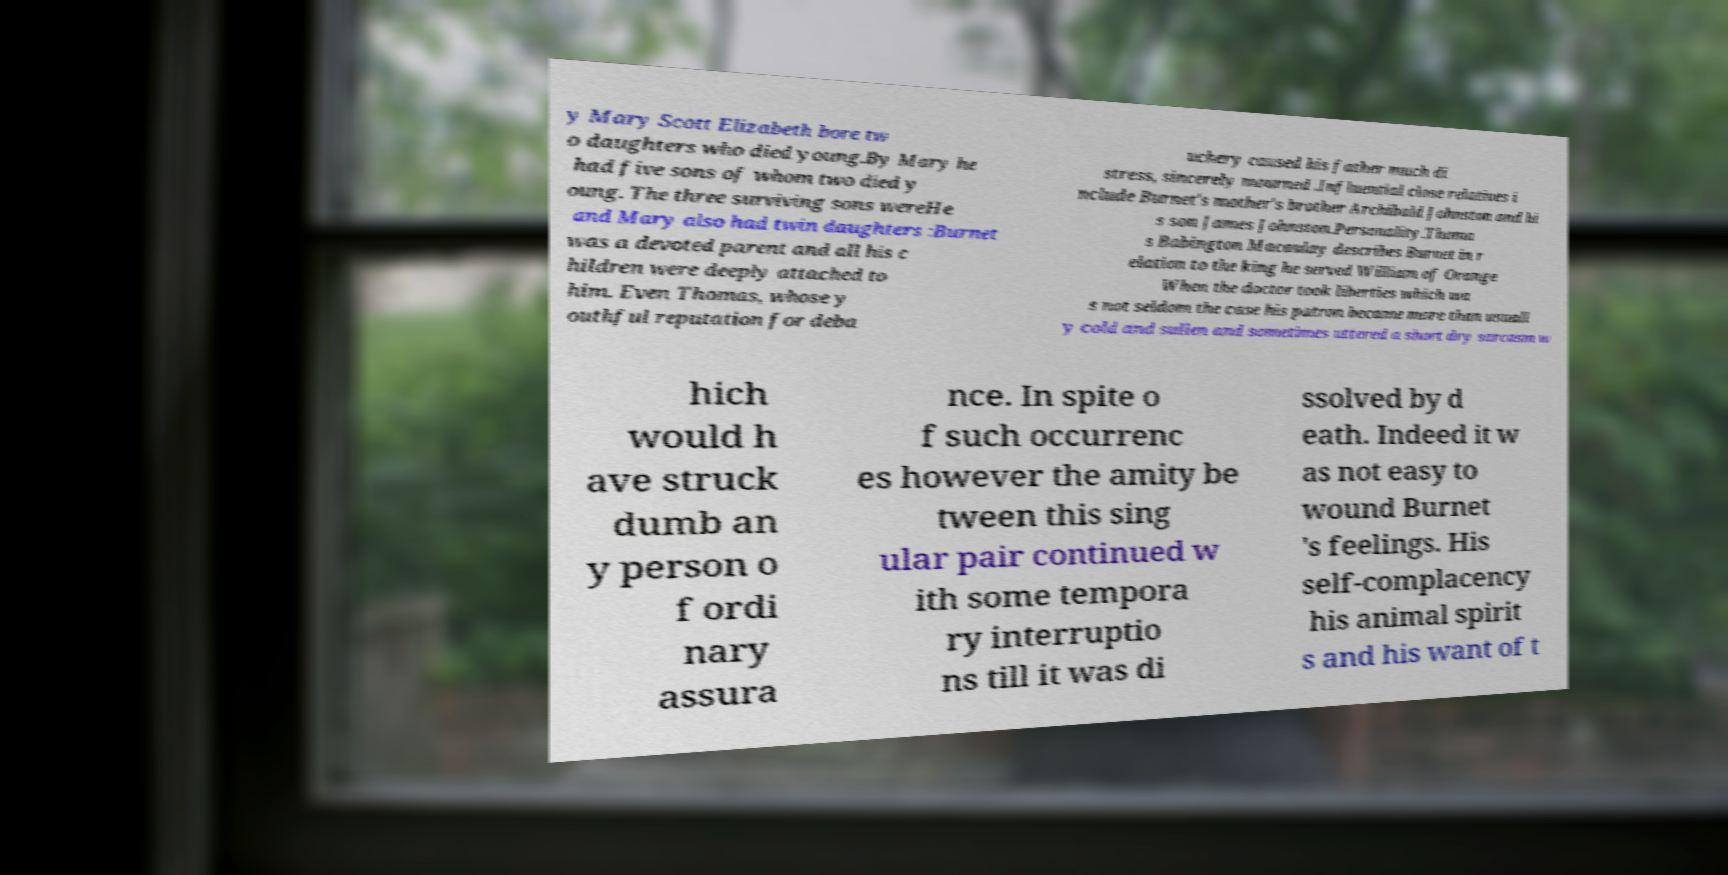Please identify and transcribe the text found in this image. y Mary Scott Elizabeth bore tw o daughters who died young.By Mary he had five sons of whom two died y oung. The three surviving sons wereHe and Mary also had twin daughters :Burnet was a devoted parent and all his c hildren were deeply attached to him. Even Thomas, whose y outhful reputation for deba uchery caused his father much di stress, sincerely mourned .Influential close relatives i nclude Burnet's mother's brother Archibald Johnston and hi s son James Johnston.Personality.Thoma s Babington Macaulay describes Burnet in r elation to the king he served William of Orange When the doctor took liberties which wa s not seldom the case his patron became more than usuall y cold and sullen and sometimes uttered a short dry sarcasm w hich would h ave struck dumb an y person o f ordi nary assura nce. In spite o f such occurrenc es however the amity be tween this sing ular pair continued w ith some tempora ry interruptio ns till it was di ssolved by d eath. Indeed it w as not easy to wound Burnet 's feelings. His self-complacency his animal spirit s and his want of t 